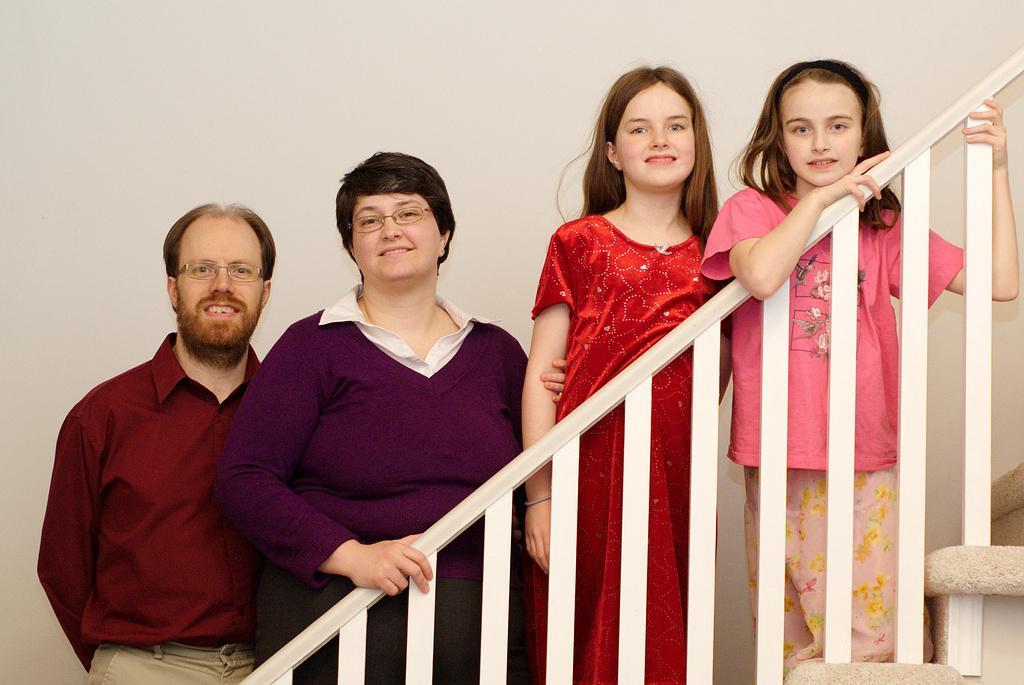How would you summarize this image in a sentence or two? In this picture we can see four persons standing on the staircase. Behind the four persons, there is a wall. 